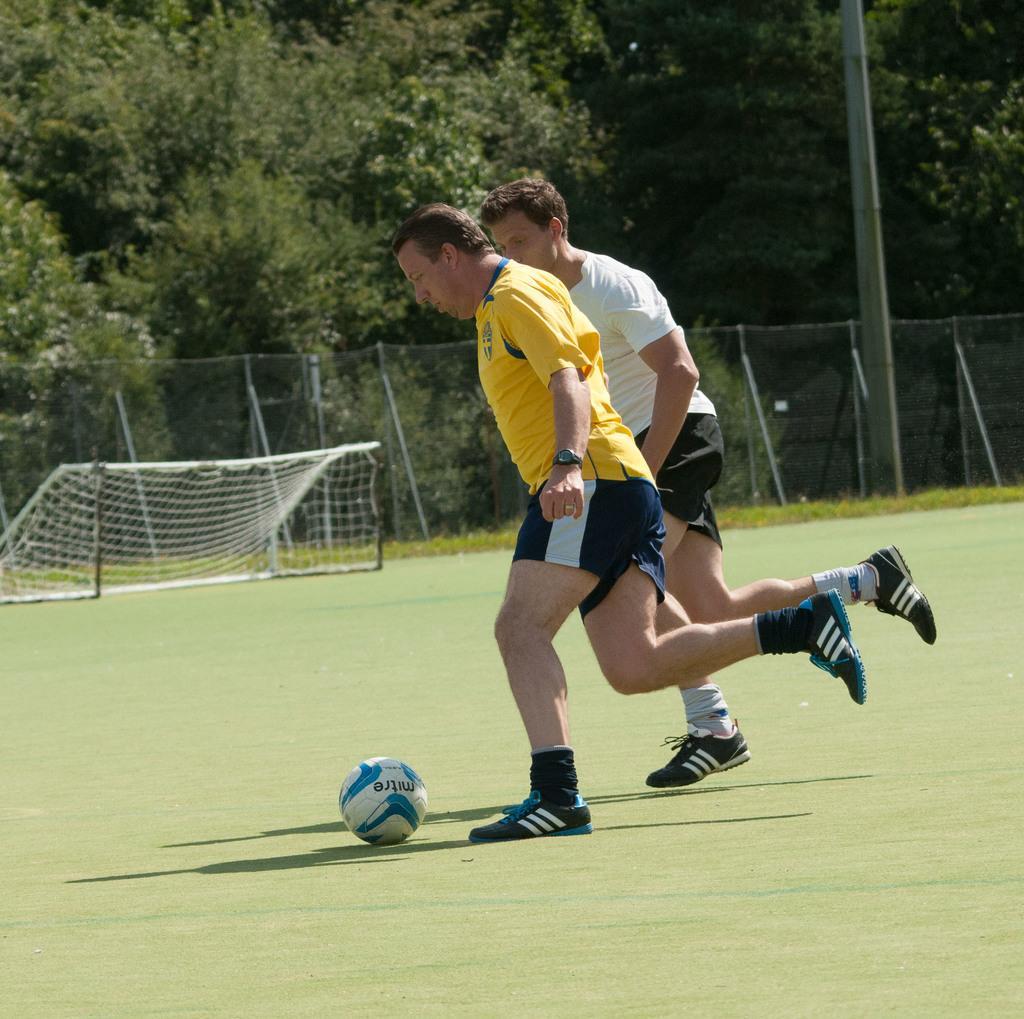In one or two sentences, can you explain what this image depicts? In this picture we can see two people and a ball on the ground and in the background we can see trees, fence, net and a pole. 